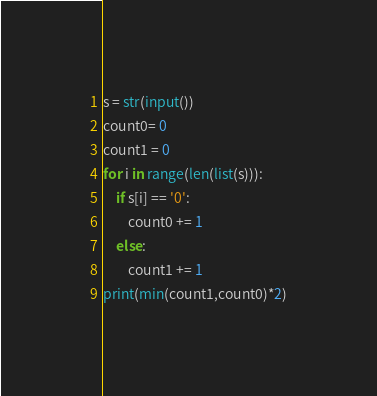<code> <loc_0><loc_0><loc_500><loc_500><_Python_>s = str(input())
count0= 0
count1 = 0
for i in range(len(list(s))):
    if s[i] == '0':
        count0 += 1
    else:
        count1 += 1
print(min(count1,count0)*2)</code> 